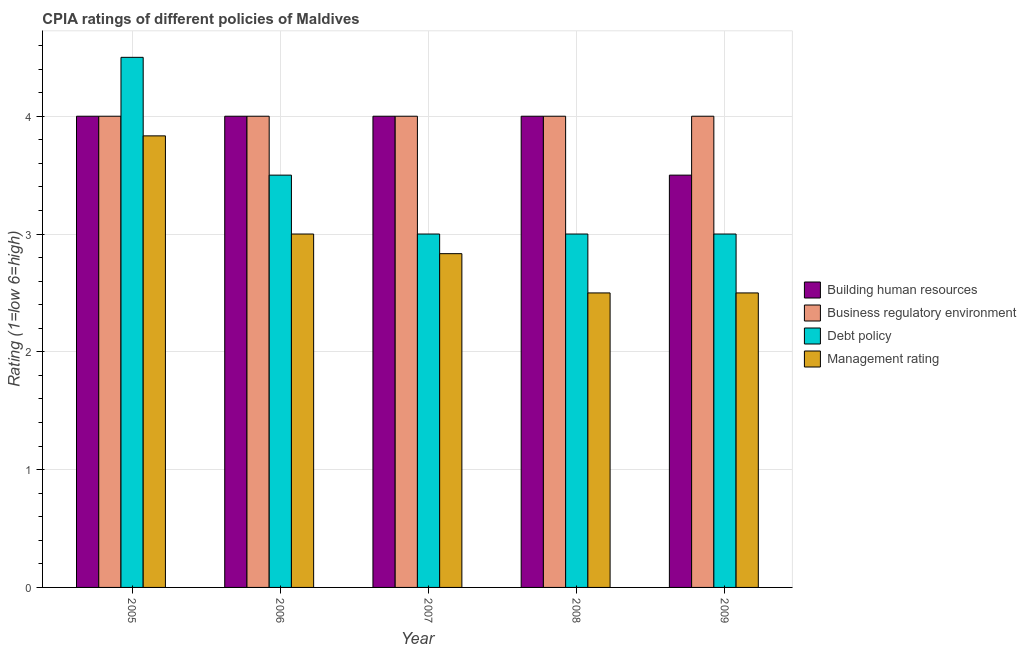How many groups of bars are there?
Make the answer very short. 5. Are the number of bars per tick equal to the number of legend labels?
Provide a succinct answer. Yes. How many bars are there on the 4th tick from the left?
Ensure brevity in your answer.  4. What is the label of the 5th group of bars from the left?
Your answer should be compact. 2009. In how many cases, is the number of bars for a given year not equal to the number of legend labels?
Ensure brevity in your answer.  0. What is the cpia rating of building human resources in 2005?
Your response must be concise. 4. Across all years, what is the maximum cpia rating of management?
Offer a terse response. 3.83. Across all years, what is the minimum cpia rating of business regulatory environment?
Give a very brief answer. 4. In which year was the cpia rating of building human resources minimum?
Your response must be concise. 2009. What is the total cpia rating of building human resources in the graph?
Ensure brevity in your answer.  19.5. In the year 2007, what is the difference between the cpia rating of management and cpia rating of business regulatory environment?
Make the answer very short. 0. In how many years, is the cpia rating of business regulatory environment greater than 1?
Provide a short and direct response. 5. What is the ratio of the cpia rating of management in 2007 to that in 2009?
Provide a short and direct response. 1.13. Is the cpia rating of management in 2006 less than that in 2009?
Provide a short and direct response. No. Is the sum of the cpia rating of management in 2007 and 2008 greater than the maximum cpia rating of business regulatory environment across all years?
Give a very brief answer. Yes. Is it the case that in every year, the sum of the cpia rating of building human resources and cpia rating of business regulatory environment is greater than the sum of cpia rating of debt policy and cpia rating of management?
Make the answer very short. No. What does the 4th bar from the left in 2005 represents?
Make the answer very short. Management rating. What does the 4th bar from the right in 2005 represents?
Your response must be concise. Building human resources. How many years are there in the graph?
Offer a very short reply. 5. What is the difference between two consecutive major ticks on the Y-axis?
Your answer should be very brief. 1. Does the graph contain grids?
Give a very brief answer. Yes. How many legend labels are there?
Provide a succinct answer. 4. What is the title of the graph?
Ensure brevity in your answer.  CPIA ratings of different policies of Maldives. Does "Water" appear as one of the legend labels in the graph?
Make the answer very short. No. What is the label or title of the Y-axis?
Provide a short and direct response. Rating (1=low 6=high). What is the Rating (1=low 6=high) of Business regulatory environment in 2005?
Offer a terse response. 4. What is the Rating (1=low 6=high) in Management rating in 2005?
Your response must be concise. 3.83. What is the Rating (1=low 6=high) in Business regulatory environment in 2006?
Keep it short and to the point. 4. What is the Rating (1=low 6=high) of Debt policy in 2006?
Offer a terse response. 3.5. What is the Rating (1=low 6=high) of Business regulatory environment in 2007?
Make the answer very short. 4. What is the Rating (1=low 6=high) in Debt policy in 2007?
Provide a succinct answer. 3. What is the Rating (1=low 6=high) of Management rating in 2007?
Your response must be concise. 2.83. What is the Rating (1=low 6=high) of Management rating in 2008?
Ensure brevity in your answer.  2.5. What is the Rating (1=low 6=high) in Business regulatory environment in 2009?
Give a very brief answer. 4. What is the Rating (1=low 6=high) in Debt policy in 2009?
Your response must be concise. 3. Across all years, what is the maximum Rating (1=low 6=high) in Business regulatory environment?
Offer a terse response. 4. Across all years, what is the maximum Rating (1=low 6=high) in Debt policy?
Give a very brief answer. 4.5. Across all years, what is the maximum Rating (1=low 6=high) in Management rating?
Offer a terse response. 3.83. Across all years, what is the minimum Rating (1=low 6=high) in Building human resources?
Keep it short and to the point. 3.5. Across all years, what is the minimum Rating (1=low 6=high) in Business regulatory environment?
Your answer should be very brief. 4. What is the total Rating (1=low 6=high) in Business regulatory environment in the graph?
Provide a short and direct response. 20. What is the total Rating (1=low 6=high) in Debt policy in the graph?
Give a very brief answer. 17. What is the total Rating (1=low 6=high) in Management rating in the graph?
Give a very brief answer. 14.67. What is the difference between the Rating (1=low 6=high) of Business regulatory environment in 2005 and that in 2006?
Your answer should be compact. 0. What is the difference between the Rating (1=low 6=high) of Building human resources in 2005 and that in 2007?
Provide a short and direct response. 0. What is the difference between the Rating (1=low 6=high) of Business regulatory environment in 2005 and that in 2007?
Make the answer very short. 0. What is the difference between the Rating (1=low 6=high) of Debt policy in 2005 and that in 2007?
Ensure brevity in your answer.  1.5. What is the difference between the Rating (1=low 6=high) of Management rating in 2005 and that in 2007?
Offer a terse response. 1. What is the difference between the Rating (1=low 6=high) of Building human resources in 2005 and that in 2008?
Offer a very short reply. 0. What is the difference between the Rating (1=low 6=high) in Management rating in 2005 and that in 2008?
Keep it short and to the point. 1.33. What is the difference between the Rating (1=low 6=high) in Management rating in 2005 and that in 2009?
Your response must be concise. 1.33. What is the difference between the Rating (1=low 6=high) in Building human resources in 2006 and that in 2007?
Provide a short and direct response. 0. What is the difference between the Rating (1=low 6=high) in Business regulatory environment in 2006 and that in 2007?
Offer a terse response. 0. What is the difference between the Rating (1=low 6=high) in Debt policy in 2006 and that in 2007?
Provide a succinct answer. 0.5. What is the difference between the Rating (1=low 6=high) of Management rating in 2006 and that in 2007?
Ensure brevity in your answer.  0.17. What is the difference between the Rating (1=low 6=high) of Building human resources in 2006 and that in 2008?
Your response must be concise. 0. What is the difference between the Rating (1=low 6=high) of Business regulatory environment in 2006 and that in 2008?
Offer a very short reply. 0. What is the difference between the Rating (1=low 6=high) in Business regulatory environment in 2006 and that in 2009?
Offer a very short reply. 0. What is the difference between the Rating (1=low 6=high) of Debt policy in 2006 and that in 2009?
Your answer should be very brief. 0.5. What is the difference between the Rating (1=low 6=high) in Building human resources in 2007 and that in 2009?
Your answer should be very brief. 0.5. What is the difference between the Rating (1=low 6=high) in Debt policy in 2007 and that in 2009?
Your answer should be very brief. 0. What is the difference between the Rating (1=low 6=high) of Business regulatory environment in 2008 and that in 2009?
Provide a succinct answer. 0. What is the difference between the Rating (1=low 6=high) of Building human resources in 2005 and the Rating (1=low 6=high) of Debt policy in 2006?
Ensure brevity in your answer.  0.5. What is the difference between the Rating (1=low 6=high) of Building human resources in 2005 and the Rating (1=low 6=high) of Debt policy in 2007?
Offer a terse response. 1. What is the difference between the Rating (1=low 6=high) of Business regulatory environment in 2005 and the Rating (1=low 6=high) of Management rating in 2007?
Your answer should be very brief. 1.17. What is the difference between the Rating (1=low 6=high) of Debt policy in 2005 and the Rating (1=low 6=high) of Management rating in 2007?
Your answer should be compact. 1.67. What is the difference between the Rating (1=low 6=high) of Building human resources in 2005 and the Rating (1=low 6=high) of Business regulatory environment in 2008?
Give a very brief answer. 0. What is the difference between the Rating (1=low 6=high) in Building human resources in 2005 and the Rating (1=low 6=high) in Management rating in 2008?
Keep it short and to the point. 1.5. What is the difference between the Rating (1=low 6=high) in Business regulatory environment in 2005 and the Rating (1=low 6=high) in Debt policy in 2008?
Your answer should be compact. 1. What is the difference between the Rating (1=low 6=high) of Building human resources in 2005 and the Rating (1=low 6=high) of Business regulatory environment in 2009?
Provide a short and direct response. 0. What is the difference between the Rating (1=low 6=high) in Business regulatory environment in 2005 and the Rating (1=low 6=high) in Debt policy in 2009?
Keep it short and to the point. 1. What is the difference between the Rating (1=low 6=high) of Business regulatory environment in 2005 and the Rating (1=low 6=high) of Management rating in 2009?
Make the answer very short. 1.5. What is the difference between the Rating (1=low 6=high) of Debt policy in 2005 and the Rating (1=low 6=high) of Management rating in 2009?
Provide a succinct answer. 2. What is the difference between the Rating (1=low 6=high) in Building human resources in 2006 and the Rating (1=low 6=high) in Business regulatory environment in 2007?
Ensure brevity in your answer.  0. What is the difference between the Rating (1=low 6=high) of Building human resources in 2006 and the Rating (1=low 6=high) of Debt policy in 2007?
Ensure brevity in your answer.  1. What is the difference between the Rating (1=low 6=high) of Business regulatory environment in 2006 and the Rating (1=low 6=high) of Debt policy in 2007?
Keep it short and to the point. 1. What is the difference between the Rating (1=low 6=high) in Building human resources in 2006 and the Rating (1=low 6=high) in Business regulatory environment in 2008?
Your answer should be compact. 0. What is the difference between the Rating (1=low 6=high) in Building human resources in 2006 and the Rating (1=low 6=high) in Business regulatory environment in 2009?
Your answer should be very brief. 0. What is the difference between the Rating (1=low 6=high) in Building human resources in 2006 and the Rating (1=low 6=high) in Debt policy in 2009?
Provide a short and direct response. 1. What is the difference between the Rating (1=low 6=high) in Building human resources in 2006 and the Rating (1=low 6=high) in Management rating in 2009?
Give a very brief answer. 1.5. What is the difference between the Rating (1=low 6=high) of Debt policy in 2006 and the Rating (1=low 6=high) of Management rating in 2009?
Ensure brevity in your answer.  1. What is the difference between the Rating (1=low 6=high) of Building human resources in 2007 and the Rating (1=low 6=high) of Debt policy in 2008?
Offer a terse response. 1. What is the difference between the Rating (1=low 6=high) in Building human resources in 2007 and the Rating (1=low 6=high) in Management rating in 2008?
Your answer should be very brief. 1.5. What is the difference between the Rating (1=low 6=high) of Business regulatory environment in 2007 and the Rating (1=low 6=high) of Debt policy in 2008?
Ensure brevity in your answer.  1. What is the difference between the Rating (1=low 6=high) in Business regulatory environment in 2007 and the Rating (1=low 6=high) in Management rating in 2008?
Your answer should be very brief. 1.5. What is the difference between the Rating (1=low 6=high) in Debt policy in 2007 and the Rating (1=low 6=high) in Management rating in 2008?
Provide a succinct answer. 0.5. What is the difference between the Rating (1=low 6=high) of Building human resources in 2007 and the Rating (1=low 6=high) of Debt policy in 2009?
Your response must be concise. 1. What is the difference between the Rating (1=low 6=high) in Building human resources in 2007 and the Rating (1=low 6=high) in Management rating in 2009?
Make the answer very short. 1.5. What is the difference between the Rating (1=low 6=high) in Building human resources in 2008 and the Rating (1=low 6=high) in Debt policy in 2009?
Your answer should be very brief. 1. What is the difference between the Rating (1=low 6=high) of Building human resources in 2008 and the Rating (1=low 6=high) of Management rating in 2009?
Give a very brief answer. 1.5. What is the average Rating (1=low 6=high) of Debt policy per year?
Ensure brevity in your answer.  3.4. What is the average Rating (1=low 6=high) of Management rating per year?
Ensure brevity in your answer.  2.93. In the year 2005, what is the difference between the Rating (1=low 6=high) of Building human resources and Rating (1=low 6=high) of Business regulatory environment?
Offer a very short reply. 0. In the year 2005, what is the difference between the Rating (1=low 6=high) of Building human resources and Rating (1=low 6=high) of Management rating?
Give a very brief answer. 0.17. In the year 2005, what is the difference between the Rating (1=low 6=high) in Business regulatory environment and Rating (1=low 6=high) in Management rating?
Offer a very short reply. 0.17. In the year 2006, what is the difference between the Rating (1=low 6=high) in Building human resources and Rating (1=low 6=high) in Debt policy?
Keep it short and to the point. 0.5. In the year 2006, what is the difference between the Rating (1=low 6=high) of Building human resources and Rating (1=low 6=high) of Management rating?
Give a very brief answer. 1. In the year 2006, what is the difference between the Rating (1=low 6=high) in Business regulatory environment and Rating (1=low 6=high) in Debt policy?
Keep it short and to the point. 0.5. In the year 2007, what is the difference between the Rating (1=low 6=high) of Business regulatory environment and Rating (1=low 6=high) of Debt policy?
Your response must be concise. 1. In the year 2007, what is the difference between the Rating (1=low 6=high) of Debt policy and Rating (1=low 6=high) of Management rating?
Ensure brevity in your answer.  0.17. In the year 2008, what is the difference between the Rating (1=low 6=high) in Building human resources and Rating (1=low 6=high) in Business regulatory environment?
Offer a terse response. 0. In the year 2008, what is the difference between the Rating (1=low 6=high) in Building human resources and Rating (1=low 6=high) in Debt policy?
Keep it short and to the point. 1. In the year 2008, what is the difference between the Rating (1=low 6=high) of Building human resources and Rating (1=low 6=high) of Management rating?
Provide a short and direct response. 1.5. In the year 2009, what is the difference between the Rating (1=low 6=high) in Building human resources and Rating (1=low 6=high) in Business regulatory environment?
Provide a succinct answer. -0.5. In the year 2009, what is the difference between the Rating (1=low 6=high) in Building human resources and Rating (1=low 6=high) in Management rating?
Keep it short and to the point. 1. What is the ratio of the Rating (1=low 6=high) in Building human resources in 2005 to that in 2006?
Give a very brief answer. 1. What is the ratio of the Rating (1=low 6=high) in Management rating in 2005 to that in 2006?
Make the answer very short. 1.28. What is the ratio of the Rating (1=low 6=high) in Building human resources in 2005 to that in 2007?
Provide a succinct answer. 1. What is the ratio of the Rating (1=low 6=high) of Management rating in 2005 to that in 2007?
Offer a terse response. 1.35. What is the ratio of the Rating (1=low 6=high) in Business regulatory environment in 2005 to that in 2008?
Offer a terse response. 1. What is the ratio of the Rating (1=low 6=high) of Debt policy in 2005 to that in 2008?
Give a very brief answer. 1.5. What is the ratio of the Rating (1=low 6=high) in Management rating in 2005 to that in 2008?
Make the answer very short. 1.53. What is the ratio of the Rating (1=low 6=high) of Business regulatory environment in 2005 to that in 2009?
Offer a very short reply. 1. What is the ratio of the Rating (1=low 6=high) of Debt policy in 2005 to that in 2009?
Ensure brevity in your answer.  1.5. What is the ratio of the Rating (1=low 6=high) of Management rating in 2005 to that in 2009?
Your response must be concise. 1.53. What is the ratio of the Rating (1=low 6=high) of Building human resources in 2006 to that in 2007?
Offer a very short reply. 1. What is the ratio of the Rating (1=low 6=high) in Business regulatory environment in 2006 to that in 2007?
Provide a succinct answer. 1. What is the ratio of the Rating (1=low 6=high) of Management rating in 2006 to that in 2007?
Provide a short and direct response. 1.06. What is the ratio of the Rating (1=low 6=high) in Management rating in 2006 to that in 2008?
Provide a succinct answer. 1.2. What is the ratio of the Rating (1=low 6=high) in Building human resources in 2006 to that in 2009?
Your answer should be very brief. 1.14. What is the ratio of the Rating (1=low 6=high) in Business regulatory environment in 2006 to that in 2009?
Your response must be concise. 1. What is the ratio of the Rating (1=low 6=high) of Debt policy in 2006 to that in 2009?
Offer a very short reply. 1.17. What is the ratio of the Rating (1=low 6=high) of Management rating in 2007 to that in 2008?
Give a very brief answer. 1.13. What is the ratio of the Rating (1=low 6=high) of Management rating in 2007 to that in 2009?
Your answer should be compact. 1.13. What is the ratio of the Rating (1=low 6=high) of Building human resources in 2008 to that in 2009?
Offer a terse response. 1.14. What is the ratio of the Rating (1=low 6=high) in Management rating in 2008 to that in 2009?
Make the answer very short. 1. What is the difference between the highest and the second highest Rating (1=low 6=high) in Business regulatory environment?
Make the answer very short. 0. What is the difference between the highest and the second highest Rating (1=low 6=high) in Debt policy?
Make the answer very short. 1. What is the difference between the highest and the second highest Rating (1=low 6=high) of Management rating?
Ensure brevity in your answer.  0.83. What is the difference between the highest and the lowest Rating (1=low 6=high) of Building human resources?
Your answer should be very brief. 0.5. What is the difference between the highest and the lowest Rating (1=low 6=high) of Business regulatory environment?
Provide a succinct answer. 0. What is the difference between the highest and the lowest Rating (1=low 6=high) in Debt policy?
Offer a terse response. 1.5. 